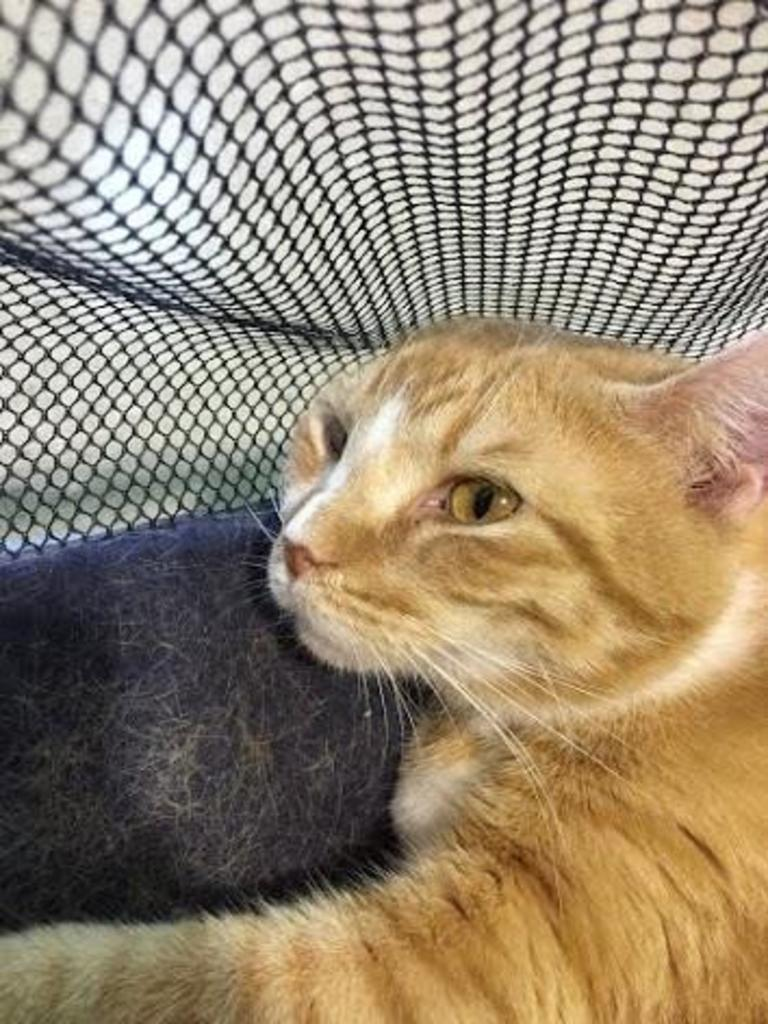What type of animal is in the image? There is a cat in the image. What is covering the cat in the image? There is a bed sheet above the cat. What type of juice is being served in the image? There is no juice present in the image; it only features a cat and a bed sheet. 